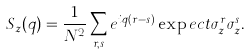<formula> <loc_0><loc_0><loc_500><loc_500>S _ { z } ( q ) = \frac { 1 } { N ^ { 2 } } \sum _ { r , s } e ^ { i q ( r - s ) } \exp e c t { \sigma _ { z } ^ { r } \sigma _ { z } ^ { s } } .</formula> 